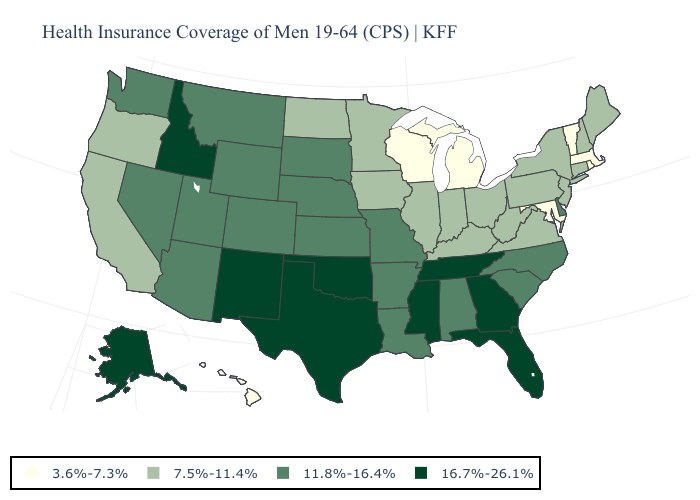What is the value of Wyoming?
Answer briefly. 11.8%-16.4%. What is the value of Washington?
Quick response, please. 11.8%-16.4%. Among the states that border Wyoming , does Utah have the highest value?
Write a very short answer. No. What is the value of Pennsylvania?
Give a very brief answer. 7.5%-11.4%. What is the highest value in the MidWest ?
Short answer required. 11.8%-16.4%. Is the legend a continuous bar?
Short answer required. No. Which states hav the highest value in the Northeast?
Concise answer only. Connecticut, Maine, New Hampshire, New Jersey, New York, Pennsylvania. Name the states that have a value in the range 11.8%-16.4%?
Keep it brief. Alabama, Arizona, Arkansas, Colorado, Delaware, Kansas, Louisiana, Missouri, Montana, Nebraska, Nevada, North Carolina, South Carolina, South Dakota, Utah, Washington, Wyoming. Among the states that border Iowa , which have the highest value?
Concise answer only. Missouri, Nebraska, South Dakota. Name the states that have a value in the range 16.7%-26.1%?
Concise answer only. Alaska, Florida, Georgia, Idaho, Mississippi, New Mexico, Oklahoma, Tennessee, Texas. Name the states that have a value in the range 3.6%-7.3%?
Concise answer only. Hawaii, Maryland, Massachusetts, Michigan, Rhode Island, Vermont, Wisconsin. Name the states that have a value in the range 11.8%-16.4%?
Give a very brief answer. Alabama, Arizona, Arkansas, Colorado, Delaware, Kansas, Louisiana, Missouri, Montana, Nebraska, Nevada, North Carolina, South Carolina, South Dakota, Utah, Washington, Wyoming. Which states have the lowest value in the USA?
Concise answer only. Hawaii, Maryland, Massachusetts, Michigan, Rhode Island, Vermont, Wisconsin. Among the states that border Tennessee , which have the highest value?
Write a very short answer. Georgia, Mississippi. What is the lowest value in the USA?
Give a very brief answer. 3.6%-7.3%. 